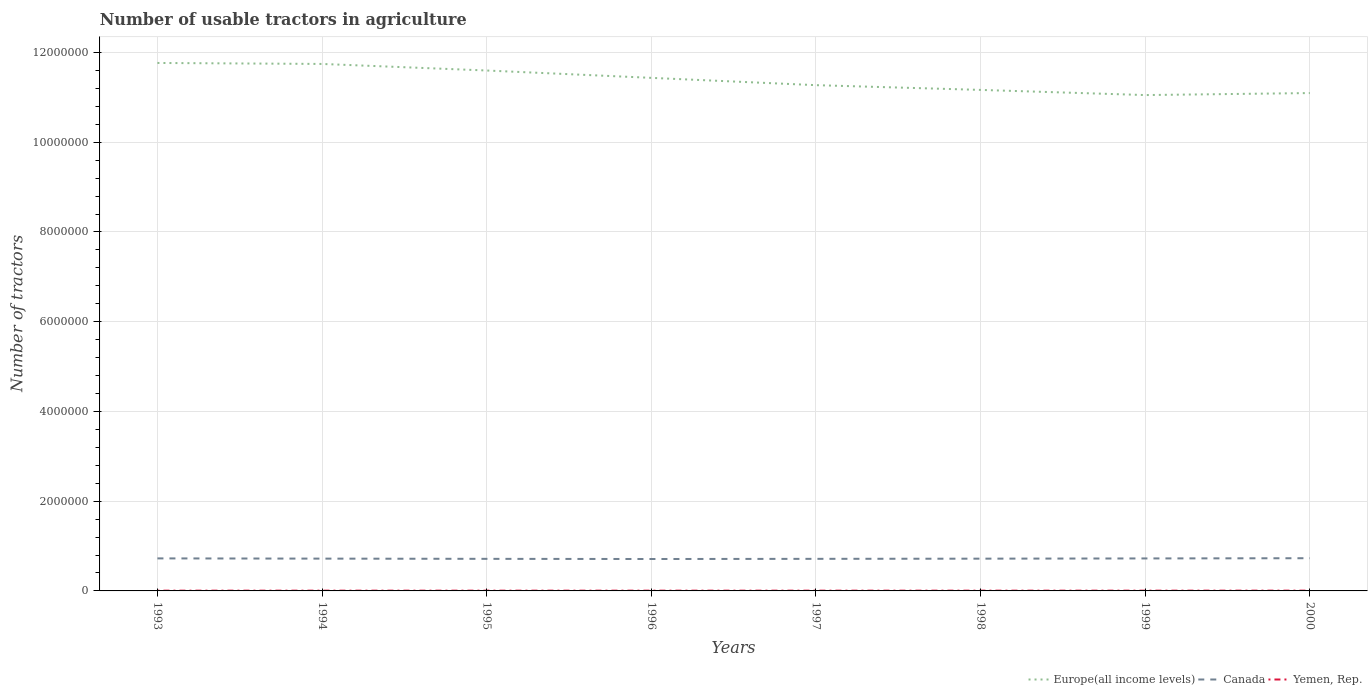Does the line corresponding to Yemen, Rep. intersect with the line corresponding to Europe(all income levels)?
Provide a succinct answer. No. Is the number of lines equal to the number of legend labels?
Your answer should be compact. Yes. Across all years, what is the maximum number of usable tractors in agriculture in Europe(all income levels)?
Give a very brief answer. 1.11e+07. In which year was the number of usable tractors in agriculture in Europe(all income levels) maximum?
Make the answer very short. 1999. What is the difference between the highest and the second highest number of usable tractors in agriculture in Canada?
Give a very brief answer. 1.77e+04. Is the number of usable tractors in agriculture in Europe(all income levels) strictly greater than the number of usable tractors in agriculture in Canada over the years?
Keep it short and to the point. No. How many lines are there?
Offer a very short reply. 3. How many years are there in the graph?
Give a very brief answer. 8. What is the difference between two consecutive major ticks on the Y-axis?
Your answer should be compact. 2.00e+06. How many legend labels are there?
Your answer should be compact. 3. What is the title of the graph?
Offer a very short reply. Number of usable tractors in agriculture. What is the label or title of the X-axis?
Offer a very short reply. Years. What is the label or title of the Y-axis?
Give a very brief answer. Number of tractors. What is the Number of tractors in Europe(all income levels) in 1993?
Offer a terse response. 1.18e+07. What is the Number of tractors in Canada in 1993?
Your response must be concise. 7.25e+05. What is the Number of tractors in Yemen, Rep. in 1993?
Keep it short and to the point. 5950. What is the Number of tractors of Europe(all income levels) in 1994?
Ensure brevity in your answer.  1.17e+07. What is the Number of tractors in Canada in 1994?
Give a very brief answer. 7.20e+05. What is the Number of tractors of Yemen, Rep. in 1994?
Make the answer very short. 5950. What is the Number of tractors of Europe(all income levels) in 1995?
Provide a short and direct response. 1.16e+07. What is the Number of tractors of Canada in 1995?
Make the answer very short. 7.15e+05. What is the Number of tractors of Yemen, Rep. in 1995?
Provide a short and direct response. 5950. What is the Number of tractors in Europe(all income levels) in 1996?
Your answer should be very brief. 1.14e+07. What is the Number of tractors in Canada in 1996?
Ensure brevity in your answer.  7.11e+05. What is the Number of tractors in Yemen, Rep. in 1996?
Provide a short and direct response. 5950. What is the Number of tractors in Europe(all income levels) in 1997?
Your answer should be very brief. 1.13e+07. What is the Number of tractors in Canada in 1997?
Offer a very short reply. 7.15e+05. What is the Number of tractors in Yemen, Rep. in 1997?
Make the answer very short. 5950. What is the Number of tractors of Europe(all income levels) in 1998?
Provide a short and direct response. 1.12e+07. What is the Number of tractors of Canada in 1998?
Make the answer very short. 7.19e+05. What is the Number of tractors in Yemen, Rep. in 1998?
Keep it short and to the point. 5950. What is the Number of tractors in Europe(all income levels) in 1999?
Offer a terse response. 1.11e+07. What is the Number of tractors of Canada in 1999?
Provide a short and direct response. 7.24e+05. What is the Number of tractors in Yemen, Rep. in 1999?
Make the answer very short. 5954. What is the Number of tractors in Europe(all income levels) in 2000?
Your response must be concise. 1.11e+07. What is the Number of tractors of Canada in 2000?
Your answer should be compact. 7.29e+05. What is the Number of tractors of Yemen, Rep. in 2000?
Provide a succinct answer. 6340. Across all years, what is the maximum Number of tractors of Europe(all income levels)?
Your response must be concise. 1.18e+07. Across all years, what is the maximum Number of tractors of Canada?
Keep it short and to the point. 7.29e+05. Across all years, what is the maximum Number of tractors in Yemen, Rep.?
Your response must be concise. 6340. Across all years, what is the minimum Number of tractors in Europe(all income levels)?
Your answer should be compact. 1.11e+07. Across all years, what is the minimum Number of tractors in Canada?
Make the answer very short. 7.11e+05. Across all years, what is the minimum Number of tractors of Yemen, Rep.?
Give a very brief answer. 5950. What is the total Number of tractors of Europe(all income levels) in the graph?
Your response must be concise. 9.11e+07. What is the total Number of tractors in Canada in the graph?
Make the answer very short. 5.76e+06. What is the total Number of tractors in Yemen, Rep. in the graph?
Ensure brevity in your answer.  4.80e+04. What is the difference between the Number of tractors of Europe(all income levels) in 1993 and that in 1994?
Your answer should be compact. 2.19e+04. What is the difference between the Number of tractors in Europe(all income levels) in 1993 and that in 1995?
Offer a terse response. 1.68e+05. What is the difference between the Number of tractors in Europe(all income levels) in 1993 and that in 1996?
Ensure brevity in your answer.  3.32e+05. What is the difference between the Number of tractors of Canada in 1993 and that in 1996?
Ensure brevity in your answer.  1.37e+04. What is the difference between the Number of tractors of Yemen, Rep. in 1993 and that in 1996?
Offer a terse response. 0. What is the difference between the Number of tractors of Europe(all income levels) in 1993 and that in 1997?
Your response must be concise. 4.95e+05. What is the difference between the Number of tractors in Europe(all income levels) in 1993 and that in 1998?
Your answer should be very brief. 6.01e+05. What is the difference between the Number of tractors of Canada in 1993 and that in 1998?
Offer a terse response. 6000. What is the difference between the Number of tractors of Europe(all income levels) in 1993 and that in 1999?
Ensure brevity in your answer.  7.16e+05. What is the difference between the Number of tractors in Canada in 1993 and that in 1999?
Make the answer very short. 1000. What is the difference between the Number of tractors in Europe(all income levels) in 1993 and that in 2000?
Provide a short and direct response. 6.71e+05. What is the difference between the Number of tractors in Canada in 1993 and that in 2000?
Your answer should be compact. -4000. What is the difference between the Number of tractors in Yemen, Rep. in 1993 and that in 2000?
Give a very brief answer. -390. What is the difference between the Number of tractors in Europe(all income levels) in 1994 and that in 1995?
Offer a very short reply. 1.46e+05. What is the difference between the Number of tractors in Canada in 1994 and that in 1995?
Ensure brevity in your answer.  5000. What is the difference between the Number of tractors of Yemen, Rep. in 1994 and that in 1995?
Give a very brief answer. 0. What is the difference between the Number of tractors in Europe(all income levels) in 1994 and that in 1996?
Provide a succinct answer. 3.10e+05. What is the difference between the Number of tractors in Canada in 1994 and that in 1996?
Offer a very short reply. 8665. What is the difference between the Number of tractors of Europe(all income levels) in 1994 and that in 1997?
Your answer should be very brief. 4.73e+05. What is the difference between the Number of tractors in Canada in 1994 and that in 1997?
Offer a very short reply. 5000. What is the difference between the Number of tractors in Europe(all income levels) in 1994 and that in 1998?
Provide a succinct answer. 5.79e+05. What is the difference between the Number of tractors of Canada in 1994 and that in 1998?
Keep it short and to the point. 1000. What is the difference between the Number of tractors of Europe(all income levels) in 1994 and that in 1999?
Offer a very short reply. 6.94e+05. What is the difference between the Number of tractors in Canada in 1994 and that in 1999?
Your answer should be compact. -4000. What is the difference between the Number of tractors in Europe(all income levels) in 1994 and that in 2000?
Give a very brief answer. 6.49e+05. What is the difference between the Number of tractors of Canada in 1994 and that in 2000?
Provide a succinct answer. -9000. What is the difference between the Number of tractors in Yemen, Rep. in 1994 and that in 2000?
Make the answer very short. -390. What is the difference between the Number of tractors in Europe(all income levels) in 1995 and that in 1996?
Your answer should be very brief. 1.64e+05. What is the difference between the Number of tractors of Canada in 1995 and that in 1996?
Provide a short and direct response. 3665. What is the difference between the Number of tractors in Yemen, Rep. in 1995 and that in 1996?
Your response must be concise. 0. What is the difference between the Number of tractors in Europe(all income levels) in 1995 and that in 1997?
Your answer should be very brief. 3.27e+05. What is the difference between the Number of tractors of Canada in 1995 and that in 1997?
Offer a terse response. 0. What is the difference between the Number of tractors in Europe(all income levels) in 1995 and that in 1998?
Provide a short and direct response. 4.32e+05. What is the difference between the Number of tractors in Canada in 1995 and that in 1998?
Give a very brief answer. -4000. What is the difference between the Number of tractors of Europe(all income levels) in 1995 and that in 1999?
Provide a succinct answer. 5.48e+05. What is the difference between the Number of tractors of Canada in 1995 and that in 1999?
Offer a very short reply. -9000. What is the difference between the Number of tractors in Yemen, Rep. in 1995 and that in 1999?
Give a very brief answer. -4. What is the difference between the Number of tractors of Europe(all income levels) in 1995 and that in 2000?
Keep it short and to the point. 5.03e+05. What is the difference between the Number of tractors in Canada in 1995 and that in 2000?
Your response must be concise. -1.40e+04. What is the difference between the Number of tractors in Yemen, Rep. in 1995 and that in 2000?
Your answer should be compact. -390. What is the difference between the Number of tractors in Europe(all income levels) in 1996 and that in 1997?
Offer a terse response. 1.63e+05. What is the difference between the Number of tractors in Canada in 1996 and that in 1997?
Provide a succinct answer. -3665. What is the difference between the Number of tractors in Yemen, Rep. in 1996 and that in 1997?
Make the answer very short. 0. What is the difference between the Number of tractors of Europe(all income levels) in 1996 and that in 1998?
Ensure brevity in your answer.  2.69e+05. What is the difference between the Number of tractors in Canada in 1996 and that in 1998?
Offer a terse response. -7665. What is the difference between the Number of tractors of Europe(all income levels) in 1996 and that in 1999?
Offer a terse response. 3.84e+05. What is the difference between the Number of tractors of Canada in 1996 and that in 1999?
Ensure brevity in your answer.  -1.27e+04. What is the difference between the Number of tractors of Europe(all income levels) in 1996 and that in 2000?
Offer a terse response. 3.39e+05. What is the difference between the Number of tractors of Canada in 1996 and that in 2000?
Offer a very short reply. -1.77e+04. What is the difference between the Number of tractors of Yemen, Rep. in 1996 and that in 2000?
Ensure brevity in your answer.  -390. What is the difference between the Number of tractors in Europe(all income levels) in 1997 and that in 1998?
Offer a terse response. 1.06e+05. What is the difference between the Number of tractors in Canada in 1997 and that in 1998?
Provide a succinct answer. -4000. What is the difference between the Number of tractors in Yemen, Rep. in 1997 and that in 1998?
Ensure brevity in your answer.  0. What is the difference between the Number of tractors in Europe(all income levels) in 1997 and that in 1999?
Make the answer very short. 2.21e+05. What is the difference between the Number of tractors of Canada in 1997 and that in 1999?
Provide a short and direct response. -9000. What is the difference between the Number of tractors of Europe(all income levels) in 1997 and that in 2000?
Provide a succinct answer. 1.76e+05. What is the difference between the Number of tractors in Canada in 1997 and that in 2000?
Your response must be concise. -1.40e+04. What is the difference between the Number of tractors in Yemen, Rep. in 1997 and that in 2000?
Offer a terse response. -390. What is the difference between the Number of tractors in Europe(all income levels) in 1998 and that in 1999?
Give a very brief answer. 1.15e+05. What is the difference between the Number of tractors of Canada in 1998 and that in 1999?
Provide a short and direct response. -5000. What is the difference between the Number of tractors of Europe(all income levels) in 1998 and that in 2000?
Your response must be concise. 7.02e+04. What is the difference between the Number of tractors of Yemen, Rep. in 1998 and that in 2000?
Offer a terse response. -390. What is the difference between the Number of tractors of Europe(all income levels) in 1999 and that in 2000?
Give a very brief answer. -4.48e+04. What is the difference between the Number of tractors of Canada in 1999 and that in 2000?
Offer a terse response. -5000. What is the difference between the Number of tractors of Yemen, Rep. in 1999 and that in 2000?
Provide a short and direct response. -386. What is the difference between the Number of tractors of Europe(all income levels) in 1993 and the Number of tractors of Canada in 1994?
Your answer should be compact. 1.10e+07. What is the difference between the Number of tractors in Europe(all income levels) in 1993 and the Number of tractors in Yemen, Rep. in 1994?
Your answer should be compact. 1.18e+07. What is the difference between the Number of tractors in Canada in 1993 and the Number of tractors in Yemen, Rep. in 1994?
Ensure brevity in your answer.  7.19e+05. What is the difference between the Number of tractors in Europe(all income levels) in 1993 and the Number of tractors in Canada in 1995?
Offer a terse response. 1.11e+07. What is the difference between the Number of tractors in Europe(all income levels) in 1993 and the Number of tractors in Yemen, Rep. in 1995?
Ensure brevity in your answer.  1.18e+07. What is the difference between the Number of tractors in Canada in 1993 and the Number of tractors in Yemen, Rep. in 1995?
Provide a short and direct response. 7.19e+05. What is the difference between the Number of tractors of Europe(all income levels) in 1993 and the Number of tractors of Canada in 1996?
Your answer should be very brief. 1.11e+07. What is the difference between the Number of tractors of Europe(all income levels) in 1993 and the Number of tractors of Yemen, Rep. in 1996?
Provide a short and direct response. 1.18e+07. What is the difference between the Number of tractors in Canada in 1993 and the Number of tractors in Yemen, Rep. in 1996?
Provide a short and direct response. 7.19e+05. What is the difference between the Number of tractors of Europe(all income levels) in 1993 and the Number of tractors of Canada in 1997?
Give a very brief answer. 1.11e+07. What is the difference between the Number of tractors in Europe(all income levels) in 1993 and the Number of tractors in Yemen, Rep. in 1997?
Ensure brevity in your answer.  1.18e+07. What is the difference between the Number of tractors in Canada in 1993 and the Number of tractors in Yemen, Rep. in 1997?
Make the answer very short. 7.19e+05. What is the difference between the Number of tractors of Europe(all income levels) in 1993 and the Number of tractors of Canada in 1998?
Offer a very short reply. 1.10e+07. What is the difference between the Number of tractors in Europe(all income levels) in 1993 and the Number of tractors in Yemen, Rep. in 1998?
Offer a terse response. 1.18e+07. What is the difference between the Number of tractors in Canada in 1993 and the Number of tractors in Yemen, Rep. in 1998?
Your response must be concise. 7.19e+05. What is the difference between the Number of tractors in Europe(all income levels) in 1993 and the Number of tractors in Canada in 1999?
Make the answer very short. 1.10e+07. What is the difference between the Number of tractors in Europe(all income levels) in 1993 and the Number of tractors in Yemen, Rep. in 1999?
Make the answer very short. 1.18e+07. What is the difference between the Number of tractors in Canada in 1993 and the Number of tractors in Yemen, Rep. in 1999?
Ensure brevity in your answer.  7.19e+05. What is the difference between the Number of tractors in Europe(all income levels) in 1993 and the Number of tractors in Canada in 2000?
Offer a very short reply. 1.10e+07. What is the difference between the Number of tractors of Europe(all income levels) in 1993 and the Number of tractors of Yemen, Rep. in 2000?
Offer a terse response. 1.18e+07. What is the difference between the Number of tractors of Canada in 1993 and the Number of tractors of Yemen, Rep. in 2000?
Provide a short and direct response. 7.19e+05. What is the difference between the Number of tractors in Europe(all income levels) in 1994 and the Number of tractors in Canada in 1995?
Your response must be concise. 1.10e+07. What is the difference between the Number of tractors in Europe(all income levels) in 1994 and the Number of tractors in Yemen, Rep. in 1995?
Offer a terse response. 1.17e+07. What is the difference between the Number of tractors in Canada in 1994 and the Number of tractors in Yemen, Rep. in 1995?
Provide a short and direct response. 7.14e+05. What is the difference between the Number of tractors in Europe(all income levels) in 1994 and the Number of tractors in Canada in 1996?
Provide a succinct answer. 1.10e+07. What is the difference between the Number of tractors of Europe(all income levels) in 1994 and the Number of tractors of Yemen, Rep. in 1996?
Your answer should be very brief. 1.17e+07. What is the difference between the Number of tractors of Canada in 1994 and the Number of tractors of Yemen, Rep. in 1996?
Provide a succinct answer. 7.14e+05. What is the difference between the Number of tractors of Europe(all income levels) in 1994 and the Number of tractors of Canada in 1997?
Offer a terse response. 1.10e+07. What is the difference between the Number of tractors of Europe(all income levels) in 1994 and the Number of tractors of Yemen, Rep. in 1997?
Make the answer very short. 1.17e+07. What is the difference between the Number of tractors in Canada in 1994 and the Number of tractors in Yemen, Rep. in 1997?
Offer a terse response. 7.14e+05. What is the difference between the Number of tractors in Europe(all income levels) in 1994 and the Number of tractors in Canada in 1998?
Your answer should be very brief. 1.10e+07. What is the difference between the Number of tractors of Europe(all income levels) in 1994 and the Number of tractors of Yemen, Rep. in 1998?
Offer a terse response. 1.17e+07. What is the difference between the Number of tractors in Canada in 1994 and the Number of tractors in Yemen, Rep. in 1998?
Offer a very short reply. 7.14e+05. What is the difference between the Number of tractors of Europe(all income levels) in 1994 and the Number of tractors of Canada in 1999?
Keep it short and to the point. 1.10e+07. What is the difference between the Number of tractors of Europe(all income levels) in 1994 and the Number of tractors of Yemen, Rep. in 1999?
Keep it short and to the point. 1.17e+07. What is the difference between the Number of tractors of Canada in 1994 and the Number of tractors of Yemen, Rep. in 1999?
Your answer should be compact. 7.14e+05. What is the difference between the Number of tractors of Europe(all income levels) in 1994 and the Number of tractors of Canada in 2000?
Offer a very short reply. 1.10e+07. What is the difference between the Number of tractors of Europe(all income levels) in 1994 and the Number of tractors of Yemen, Rep. in 2000?
Your response must be concise. 1.17e+07. What is the difference between the Number of tractors of Canada in 1994 and the Number of tractors of Yemen, Rep. in 2000?
Your answer should be very brief. 7.14e+05. What is the difference between the Number of tractors of Europe(all income levels) in 1995 and the Number of tractors of Canada in 1996?
Your answer should be compact. 1.09e+07. What is the difference between the Number of tractors of Europe(all income levels) in 1995 and the Number of tractors of Yemen, Rep. in 1996?
Your response must be concise. 1.16e+07. What is the difference between the Number of tractors in Canada in 1995 and the Number of tractors in Yemen, Rep. in 1996?
Keep it short and to the point. 7.09e+05. What is the difference between the Number of tractors in Europe(all income levels) in 1995 and the Number of tractors in Canada in 1997?
Offer a terse response. 1.09e+07. What is the difference between the Number of tractors in Europe(all income levels) in 1995 and the Number of tractors in Yemen, Rep. in 1997?
Your response must be concise. 1.16e+07. What is the difference between the Number of tractors of Canada in 1995 and the Number of tractors of Yemen, Rep. in 1997?
Provide a succinct answer. 7.09e+05. What is the difference between the Number of tractors in Europe(all income levels) in 1995 and the Number of tractors in Canada in 1998?
Your answer should be compact. 1.09e+07. What is the difference between the Number of tractors of Europe(all income levels) in 1995 and the Number of tractors of Yemen, Rep. in 1998?
Give a very brief answer. 1.16e+07. What is the difference between the Number of tractors of Canada in 1995 and the Number of tractors of Yemen, Rep. in 1998?
Your answer should be compact. 7.09e+05. What is the difference between the Number of tractors of Europe(all income levels) in 1995 and the Number of tractors of Canada in 1999?
Give a very brief answer. 1.09e+07. What is the difference between the Number of tractors of Europe(all income levels) in 1995 and the Number of tractors of Yemen, Rep. in 1999?
Your response must be concise. 1.16e+07. What is the difference between the Number of tractors of Canada in 1995 and the Number of tractors of Yemen, Rep. in 1999?
Offer a terse response. 7.09e+05. What is the difference between the Number of tractors of Europe(all income levels) in 1995 and the Number of tractors of Canada in 2000?
Provide a short and direct response. 1.09e+07. What is the difference between the Number of tractors in Europe(all income levels) in 1995 and the Number of tractors in Yemen, Rep. in 2000?
Your answer should be very brief. 1.16e+07. What is the difference between the Number of tractors in Canada in 1995 and the Number of tractors in Yemen, Rep. in 2000?
Provide a short and direct response. 7.09e+05. What is the difference between the Number of tractors in Europe(all income levels) in 1996 and the Number of tractors in Canada in 1997?
Provide a short and direct response. 1.07e+07. What is the difference between the Number of tractors in Europe(all income levels) in 1996 and the Number of tractors in Yemen, Rep. in 1997?
Provide a short and direct response. 1.14e+07. What is the difference between the Number of tractors of Canada in 1996 and the Number of tractors of Yemen, Rep. in 1997?
Your answer should be very brief. 7.05e+05. What is the difference between the Number of tractors in Europe(all income levels) in 1996 and the Number of tractors in Canada in 1998?
Keep it short and to the point. 1.07e+07. What is the difference between the Number of tractors of Europe(all income levels) in 1996 and the Number of tractors of Yemen, Rep. in 1998?
Provide a short and direct response. 1.14e+07. What is the difference between the Number of tractors in Canada in 1996 and the Number of tractors in Yemen, Rep. in 1998?
Offer a terse response. 7.05e+05. What is the difference between the Number of tractors in Europe(all income levels) in 1996 and the Number of tractors in Canada in 1999?
Offer a very short reply. 1.07e+07. What is the difference between the Number of tractors of Europe(all income levels) in 1996 and the Number of tractors of Yemen, Rep. in 1999?
Provide a succinct answer. 1.14e+07. What is the difference between the Number of tractors in Canada in 1996 and the Number of tractors in Yemen, Rep. in 1999?
Your answer should be compact. 7.05e+05. What is the difference between the Number of tractors of Europe(all income levels) in 1996 and the Number of tractors of Canada in 2000?
Your response must be concise. 1.07e+07. What is the difference between the Number of tractors in Europe(all income levels) in 1996 and the Number of tractors in Yemen, Rep. in 2000?
Your answer should be very brief. 1.14e+07. What is the difference between the Number of tractors of Canada in 1996 and the Number of tractors of Yemen, Rep. in 2000?
Offer a terse response. 7.05e+05. What is the difference between the Number of tractors in Europe(all income levels) in 1997 and the Number of tractors in Canada in 1998?
Provide a succinct answer. 1.06e+07. What is the difference between the Number of tractors of Europe(all income levels) in 1997 and the Number of tractors of Yemen, Rep. in 1998?
Give a very brief answer. 1.13e+07. What is the difference between the Number of tractors of Canada in 1997 and the Number of tractors of Yemen, Rep. in 1998?
Make the answer very short. 7.09e+05. What is the difference between the Number of tractors of Europe(all income levels) in 1997 and the Number of tractors of Canada in 1999?
Offer a very short reply. 1.05e+07. What is the difference between the Number of tractors of Europe(all income levels) in 1997 and the Number of tractors of Yemen, Rep. in 1999?
Give a very brief answer. 1.13e+07. What is the difference between the Number of tractors of Canada in 1997 and the Number of tractors of Yemen, Rep. in 1999?
Offer a terse response. 7.09e+05. What is the difference between the Number of tractors in Europe(all income levels) in 1997 and the Number of tractors in Canada in 2000?
Ensure brevity in your answer.  1.05e+07. What is the difference between the Number of tractors in Europe(all income levels) in 1997 and the Number of tractors in Yemen, Rep. in 2000?
Give a very brief answer. 1.13e+07. What is the difference between the Number of tractors of Canada in 1997 and the Number of tractors of Yemen, Rep. in 2000?
Give a very brief answer. 7.09e+05. What is the difference between the Number of tractors in Europe(all income levels) in 1998 and the Number of tractors in Canada in 1999?
Your answer should be compact. 1.04e+07. What is the difference between the Number of tractors of Europe(all income levels) in 1998 and the Number of tractors of Yemen, Rep. in 1999?
Provide a short and direct response. 1.12e+07. What is the difference between the Number of tractors of Canada in 1998 and the Number of tractors of Yemen, Rep. in 1999?
Your answer should be compact. 7.13e+05. What is the difference between the Number of tractors in Europe(all income levels) in 1998 and the Number of tractors in Canada in 2000?
Keep it short and to the point. 1.04e+07. What is the difference between the Number of tractors in Europe(all income levels) in 1998 and the Number of tractors in Yemen, Rep. in 2000?
Give a very brief answer. 1.12e+07. What is the difference between the Number of tractors in Canada in 1998 and the Number of tractors in Yemen, Rep. in 2000?
Keep it short and to the point. 7.13e+05. What is the difference between the Number of tractors of Europe(all income levels) in 1999 and the Number of tractors of Canada in 2000?
Make the answer very short. 1.03e+07. What is the difference between the Number of tractors in Europe(all income levels) in 1999 and the Number of tractors in Yemen, Rep. in 2000?
Make the answer very short. 1.10e+07. What is the difference between the Number of tractors in Canada in 1999 and the Number of tractors in Yemen, Rep. in 2000?
Offer a very short reply. 7.18e+05. What is the average Number of tractors in Europe(all income levels) per year?
Offer a very short reply. 1.14e+07. What is the average Number of tractors in Canada per year?
Your response must be concise. 7.20e+05. What is the average Number of tractors in Yemen, Rep. per year?
Your answer should be compact. 5999.25. In the year 1993, what is the difference between the Number of tractors in Europe(all income levels) and Number of tractors in Canada?
Your response must be concise. 1.10e+07. In the year 1993, what is the difference between the Number of tractors in Europe(all income levels) and Number of tractors in Yemen, Rep.?
Provide a succinct answer. 1.18e+07. In the year 1993, what is the difference between the Number of tractors in Canada and Number of tractors in Yemen, Rep.?
Offer a terse response. 7.19e+05. In the year 1994, what is the difference between the Number of tractors in Europe(all income levels) and Number of tractors in Canada?
Provide a succinct answer. 1.10e+07. In the year 1994, what is the difference between the Number of tractors of Europe(all income levels) and Number of tractors of Yemen, Rep.?
Your response must be concise. 1.17e+07. In the year 1994, what is the difference between the Number of tractors in Canada and Number of tractors in Yemen, Rep.?
Your response must be concise. 7.14e+05. In the year 1995, what is the difference between the Number of tractors of Europe(all income levels) and Number of tractors of Canada?
Provide a succinct answer. 1.09e+07. In the year 1995, what is the difference between the Number of tractors of Europe(all income levels) and Number of tractors of Yemen, Rep.?
Offer a terse response. 1.16e+07. In the year 1995, what is the difference between the Number of tractors in Canada and Number of tractors in Yemen, Rep.?
Ensure brevity in your answer.  7.09e+05. In the year 1996, what is the difference between the Number of tractors in Europe(all income levels) and Number of tractors in Canada?
Your answer should be compact. 1.07e+07. In the year 1996, what is the difference between the Number of tractors of Europe(all income levels) and Number of tractors of Yemen, Rep.?
Offer a terse response. 1.14e+07. In the year 1996, what is the difference between the Number of tractors in Canada and Number of tractors in Yemen, Rep.?
Provide a short and direct response. 7.05e+05. In the year 1997, what is the difference between the Number of tractors in Europe(all income levels) and Number of tractors in Canada?
Your answer should be compact. 1.06e+07. In the year 1997, what is the difference between the Number of tractors in Europe(all income levels) and Number of tractors in Yemen, Rep.?
Your answer should be very brief. 1.13e+07. In the year 1997, what is the difference between the Number of tractors in Canada and Number of tractors in Yemen, Rep.?
Give a very brief answer. 7.09e+05. In the year 1998, what is the difference between the Number of tractors in Europe(all income levels) and Number of tractors in Canada?
Your answer should be compact. 1.04e+07. In the year 1998, what is the difference between the Number of tractors of Europe(all income levels) and Number of tractors of Yemen, Rep.?
Provide a short and direct response. 1.12e+07. In the year 1998, what is the difference between the Number of tractors in Canada and Number of tractors in Yemen, Rep.?
Ensure brevity in your answer.  7.13e+05. In the year 1999, what is the difference between the Number of tractors of Europe(all income levels) and Number of tractors of Canada?
Your response must be concise. 1.03e+07. In the year 1999, what is the difference between the Number of tractors of Europe(all income levels) and Number of tractors of Yemen, Rep.?
Provide a succinct answer. 1.10e+07. In the year 1999, what is the difference between the Number of tractors of Canada and Number of tractors of Yemen, Rep.?
Make the answer very short. 7.18e+05. In the year 2000, what is the difference between the Number of tractors in Europe(all income levels) and Number of tractors in Canada?
Offer a terse response. 1.04e+07. In the year 2000, what is the difference between the Number of tractors of Europe(all income levels) and Number of tractors of Yemen, Rep.?
Make the answer very short. 1.11e+07. In the year 2000, what is the difference between the Number of tractors of Canada and Number of tractors of Yemen, Rep.?
Your answer should be compact. 7.23e+05. What is the ratio of the Number of tractors in Canada in 1993 to that in 1994?
Give a very brief answer. 1.01. What is the ratio of the Number of tractors in Yemen, Rep. in 1993 to that in 1994?
Provide a short and direct response. 1. What is the ratio of the Number of tractors in Europe(all income levels) in 1993 to that in 1995?
Your response must be concise. 1.01. What is the ratio of the Number of tractors of Yemen, Rep. in 1993 to that in 1995?
Provide a short and direct response. 1. What is the ratio of the Number of tractors of Canada in 1993 to that in 1996?
Keep it short and to the point. 1.02. What is the ratio of the Number of tractors of Europe(all income levels) in 1993 to that in 1997?
Your answer should be compact. 1.04. What is the ratio of the Number of tractors in Canada in 1993 to that in 1997?
Provide a short and direct response. 1.01. What is the ratio of the Number of tractors of Yemen, Rep. in 1993 to that in 1997?
Offer a very short reply. 1. What is the ratio of the Number of tractors in Europe(all income levels) in 1993 to that in 1998?
Your answer should be very brief. 1.05. What is the ratio of the Number of tractors in Canada in 1993 to that in 1998?
Your answer should be compact. 1.01. What is the ratio of the Number of tractors of Europe(all income levels) in 1993 to that in 1999?
Offer a terse response. 1.06. What is the ratio of the Number of tractors in Europe(all income levels) in 1993 to that in 2000?
Offer a very short reply. 1.06. What is the ratio of the Number of tractors of Canada in 1993 to that in 2000?
Your answer should be compact. 0.99. What is the ratio of the Number of tractors of Yemen, Rep. in 1993 to that in 2000?
Your response must be concise. 0.94. What is the ratio of the Number of tractors in Europe(all income levels) in 1994 to that in 1995?
Provide a short and direct response. 1.01. What is the ratio of the Number of tractors in Europe(all income levels) in 1994 to that in 1996?
Offer a very short reply. 1.03. What is the ratio of the Number of tractors in Canada in 1994 to that in 1996?
Your response must be concise. 1.01. What is the ratio of the Number of tractors of Yemen, Rep. in 1994 to that in 1996?
Your response must be concise. 1. What is the ratio of the Number of tractors of Europe(all income levels) in 1994 to that in 1997?
Your answer should be very brief. 1.04. What is the ratio of the Number of tractors in Yemen, Rep. in 1994 to that in 1997?
Your response must be concise. 1. What is the ratio of the Number of tractors of Europe(all income levels) in 1994 to that in 1998?
Your answer should be very brief. 1.05. What is the ratio of the Number of tractors of Europe(all income levels) in 1994 to that in 1999?
Make the answer very short. 1.06. What is the ratio of the Number of tractors of Canada in 1994 to that in 1999?
Give a very brief answer. 0.99. What is the ratio of the Number of tractors in Europe(all income levels) in 1994 to that in 2000?
Ensure brevity in your answer.  1.06. What is the ratio of the Number of tractors in Canada in 1994 to that in 2000?
Your answer should be compact. 0.99. What is the ratio of the Number of tractors of Yemen, Rep. in 1994 to that in 2000?
Provide a succinct answer. 0.94. What is the ratio of the Number of tractors of Europe(all income levels) in 1995 to that in 1996?
Offer a terse response. 1.01. What is the ratio of the Number of tractors in Canada in 1995 to that in 1996?
Your answer should be very brief. 1.01. What is the ratio of the Number of tractors of Canada in 1995 to that in 1997?
Offer a terse response. 1. What is the ratio of the Number of tractors in Yemen, Rep. in 1995 to that in 1997?
Your answer should be compact. 1. What is the ratio of the Number of tractors in Europe(all income levels) in 1995 to that in 1998?
Your response must be concise. 1.04. What is the ratio of the Number of tractors of Canada in 1995 to that in 1998?
Provide a succinct answer. 0.99. What is the ratio of the Number of tractors of Europe(all income levels) in 1995 to that in 1999?
Ensure brevity in your answer.  1.05. What is the ratio of the Number of tractors in Canada in 1995 to that in 1999?
Offer a very short reply. 0.99. What is the ratio of the Number of tractors of Yemen, Rep. in 1995 to that in 1999?
Offer a terse response. 1. What is the ratio of the Number of tractors in Europe(all income levels) in 1995 to that in 2000?
Provide a succinct answer. 1.05. What is the ratio of the Number of tractors of Canada in 1995 to that in 2000?
Give a very brief answer. 0.98. What is the ratio of the Number of tractors in Yemen, Rep. in 1995 to that in 2000?
Keep it short and to the point. 0.94. What is the ratio of the Number of tractors in Europe(all income levels) in 1996 to that in 1997?
Provide a short and direct response. 1.01. What is the ratio of the Number of tractors of Yemen, Rep. in 1996 to that in 1997?
Provide a short and direct response. 1. What is the ratio of the Number of tractors in Europe(all income levels) in 1996 to that in 1998?
Provide a short and direct response. 1.02. What is the ratio of the Number of tractors of Canada in 1996 to that in 1998?
Make the answer very short. 0.99. What is the ratio of the Number of tractors in Europe(all income levels) in 1996 to that in 1999?
Provide a succinct answer. 1.03. What is the ratio of the Number of tractors in Canada in 1996 to that in 1999?
Your response must be concise. 0.98. What is the ratio of the Number of tractors of Yemen, Rep. in 1996 to that in 1999?
Offer a terse response. 1. What is the ratio of the Number of tractors in Europe(all income levels) in 1996 to that in 2000?
Provide a short and direct response. 1.03. What is the ratio of the Number of tractors in Canada in 1996 to that in 2000?
Make the answer very short. 0.98. What is the ratio of the Number of tractors in Yemen, Rep. in 1996 to that in 2000?
Make the answer very short. 0.94. What is the ratio of the Number of tractors of Europe(all income levels) in 1997 to that in 1998?
Make the answer very short. 1.01. What is the ratio of the Number of tractors of Canada in 1997 to that in 1999?
Provide a short and direct response. 0.99. What is the ratio of the Number of tractors in Yemen, Rep. in 1997 to that in 1999?
Make the answer very short. 1. What is the ratio of the Number of tractors in Europe(all income levels) in 1997 to that in 2000?
Ensure brevity in your answer.  1.02. What is the ratio of the Number of tractors of Canada in 1997 to that in 2000?
Your answer should be very brief. 0.98. What is the ratio of the Number of tractors of Yemen, Rep. in 1997 to that in 2000?
Offer a terse response. 0.94. What is the ratio of the Number of tractors of Europe(all income levels) in 1998 to that in 1999?
Give a very brief answer. 1.01. What is the ratio of the Number of tractors of Canada in 1998 to that in 1999?
Give a very brief answer. 0.99. What is the ratio of the Number of tractors of Canada in 1998 to that in 2000?
Your response must be concise. 0.99. What is the ratio of the Number of tractors in Yemen, Rep. in 1998 to that in 2000?
Your answer should be compact. 0.94. What is the ratio of the Number of tractors in Europe(all income levels) in 1999 to that in 2000?
Provide a short and direct response. 1. What is the ratio of the Number of tractors in Yemen, Rep. in 1999 to that in 2000?
Keep it short and to the point. 0.94. What is the difference between the highest and the second highest Number of tractors of Europe(all income levels)?
Your answer should be very brief. 2.19e+04. What is the difference between the highest and the second highest Number of tractors of Canada?
Keep it short and to the point. 4000. What is the difference between the highest and the second highest Number of tractors of Yemen, Rep.?
Your answer should be compact. 386. What is the difference between the highest and the lowest Number of tractors in Europe(all income levels)?
Make the answer very short. 7.16e+05. What is the difference between the highest and the lowest Number of tractors in Canada?
Your answer should be compact. 1.77e+04. What is the difference between the highest and the lowest Number of tractors in Yemen, Rep.?
Ensure brevity in your answer.  390. 